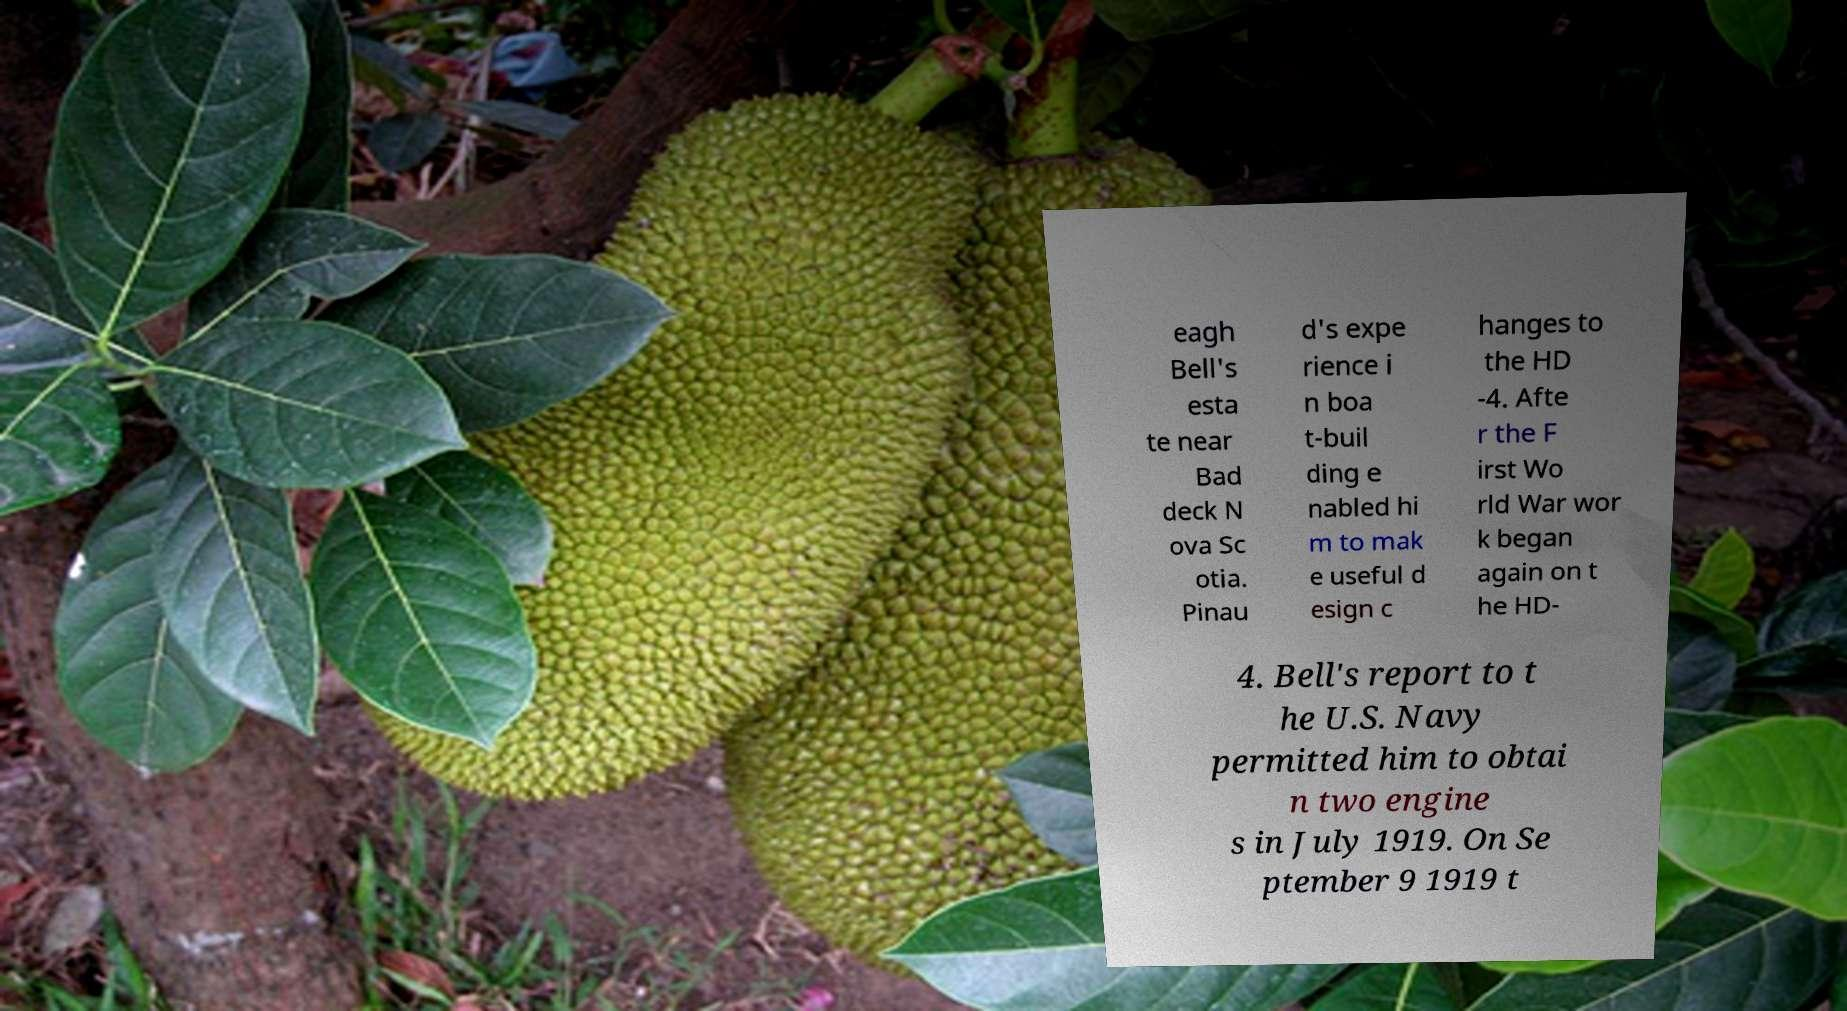Please read and relay the text visible in this image. What does it say? eagh Bell's esta te near Bad deck N ova Sc otia. Pinau d's expe rience i n boa t-buil ding e nabled hi m to mak e useful d esign c hanges to the HD -4. Afte r the F irst Wo rld War wor k began again on t he HD- 4. Bell's report to t he U.S. Navy permitted him to obtai n two engine s in July 1919. On Se ptember 9 1919 t 